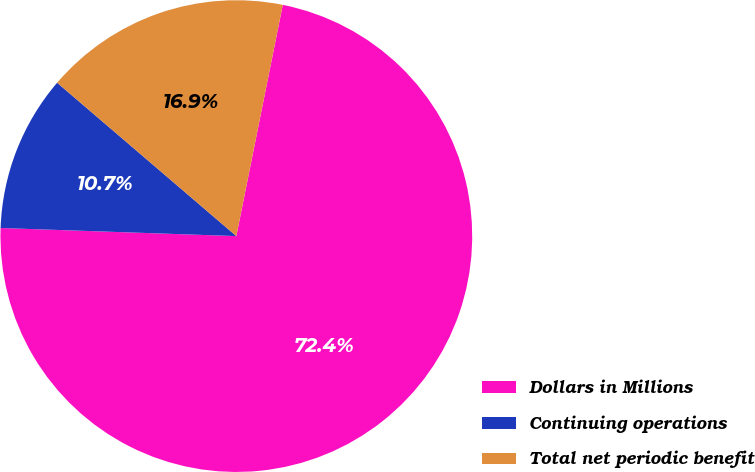Convert chart. <chart><loc_0><loc_0><loc_500><loc_500><pie_chart><fcel>Dollars in Millions<fcel>Continuing operations<fcel>Total net periodic benefit<nl><fcel>72.4%<fcel>10.72%<fcel>16.89%<nl></chart> 